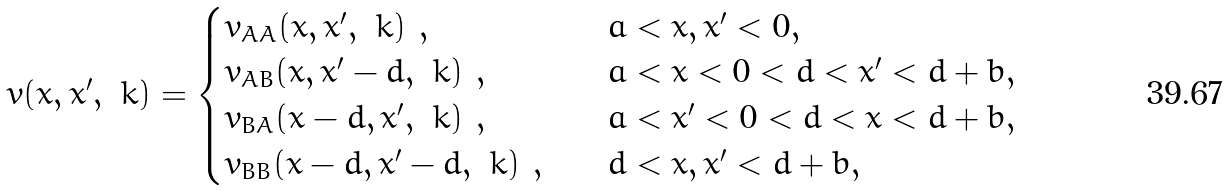Convert formula to latex. <formula><loc_0><loc_0><loc_500><loc_500>& v ( x , x ^ { \prime } , \ k ) = \begin{cases} v _ { A A } ( x , x ^ { \prime } , \ k ) \ , & \quad a < x , x ^ { \prime } < 0 , \\ v _ { A B } ( x , x ^ { \prime } - d , \ k ) \ , & \quad a < x < 0 < d < x ^ { \prime } < d + b , \\ v _ { B A } ( x - d , x ^ { \prime } , \ k ) \ , & \quad a < x ^ { \prime } < 0 < d < x < d + b , \\ v _ { B B } ( x - d , x ^ { \prime } - d , \ k ) \ , & \quad d < x , x ^ { \prime } < d + b , \end{cases}</formula> 